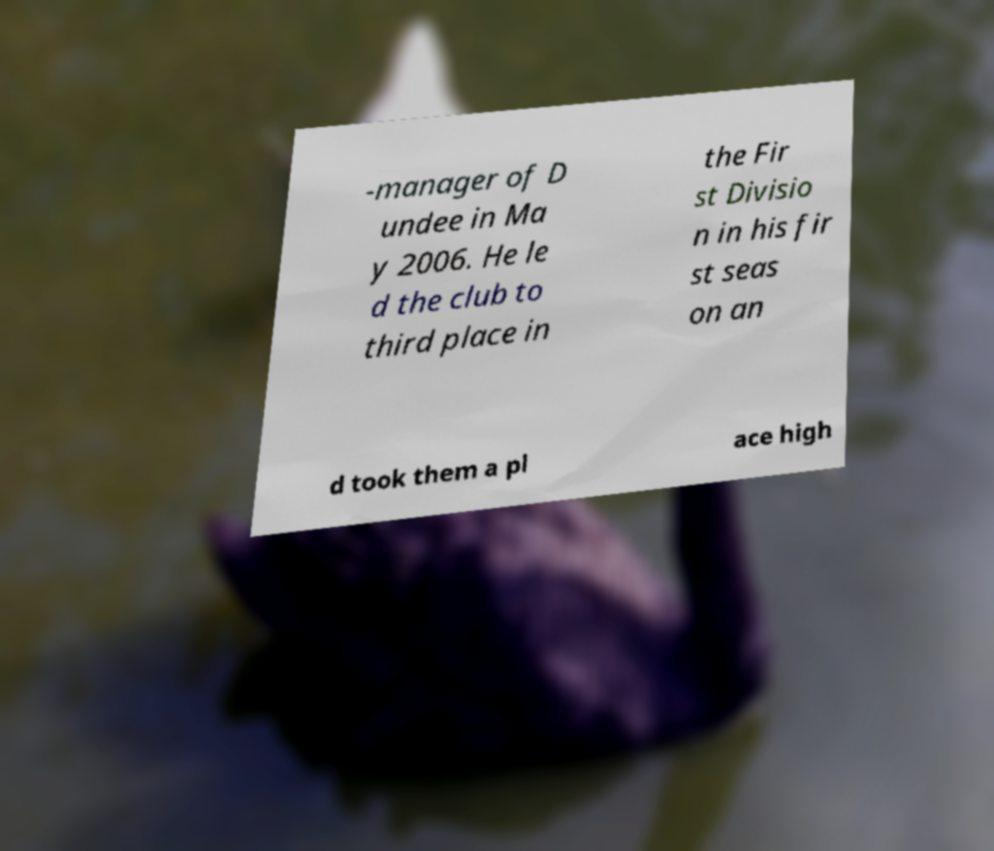Please read and relay the text visible in this image. What does it say? -manager of D undee in Ma y 2006. He le d the club to third place in the Fir st Divisio n in his fir st seas on an d took them a pl ace high 